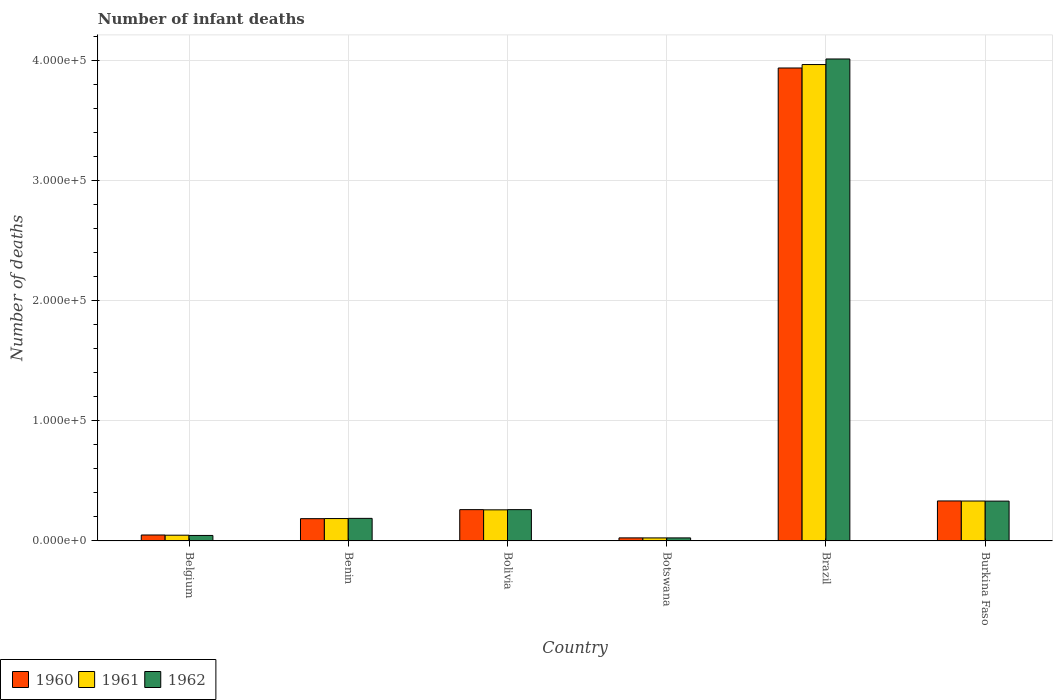How many different coloured bars are there?
Give a very brief answer. 3. How many groups of bars are there?
Give a very brief answer. 6. Are the number of bars per tick equal to the number of legend labels?
Offer a very short reply. Yes. In how many cases, is the number of bars for a given country not equal to the number of legend labels?
Make the answer very short. 0. What is the number of infant deaths in 1960 in Benin?
Offer a terse response. 1.85e+04. Across all countries, what is the maximum number of infant deaths in 1961?
Offer a terse response. 3.96e+05. Across all countries, what is the minimum number of infant deaths in 1962?
Offer a very short reply. 2530. In which country was the number of infant deaths in 1962 maximum?
Make the answer very short. Brazil. In which country was the number of infant deaths in 1960 minimum?
Make the answer very short. Botswana. What is the total number of infant deaths in 1962 in the graph?
Offer a terse response. 4.86e+05. What is the difference between the number of infant deaths in 1961 in Bolivia and that in Burkina Faso?
Provide a succinct answer. -7331. What is the difference between the number of infant deaths in 1960 in Belgium and the number of infant deaths in 1961 in Bolivia?
Your answer should be compact. -2.09e+04. What is the average number of infant deaths in 1961 per country?
Provide a short and direct response. 8.02e+04. What is the difference between the number of infant deaths of/in 1961 and number of infant deaths of/in 1962 in Bolivia?
Make the answer very short. -173. In how many countries, is the number of infant deaths in 1960 greater than 40000?
Provide a succinct answer. 1. What is the ratio of the number of infant deaths in 1961 in Benin to that in Brazil?
Provide a short and direct response. 0.05. What is the difference between the highest and the second highest number of infant deaths in 1962?
Provide a succinct answer. 7079. What is the difference between the highest and the lowest number of infant deaths in 1962?
Your answer should be very brief. 3.98e+05. Is the sum of the number of infant deaths in 1962 in Brazil and Burkina Faso greater than the maximum number of infant deaths in 1961 across all countries?
Provide a succinct answer. Yes. How many bars are there?
Give a very brief answer. 18. What is the difference between two consecutive major ticks on the Y-axis?
Make the answer very short. 1.00e+05. Are the values on the major ticks of Y-axis written in scientific E-notation?
Ensure brevity in your answer.  Yes. Does the graph contain any zero values?
Offer a very short reply. No. Where does the legend appear in the graph?
Your response must be concise. Bottom left. What is the title of the graph?
Ensure brevity in your answer.  Number of infant deaths. Does "1986" appear as one of the legend labels in the graph?
Offer a terse response. No. What is the label or title of the Y-axis?
Your answer should be very brief. Number of deaths. What is the Number of deaths of 1960 in Belgium?
Give a very brief answer. 4942. What is the Number of deaths of 1961 in Belgium?
Give a very brief answer. 4783. What is the Number of deaths of 1962 in Belgium?
Offer a very short reply. 4571. What is the Number of deaths in 1960 in Benin?
Offer a terse response. 1.85e+04. What is the Number of deaths in 1961 in Benin?
Offer a very short reply. 1.86e+04. What is the Number of deaths in 1962 in Benin?
Give a very brief answer. 1.88e+04. What is the Number of deaths in 1960 in Bolivia?
Offer a very short reply. 2.60e+04. What is the Number of deaths of 1961 in Bolivia?
Your response must be concise. 2.59e+04. What is the Number of deaths of 1962 in Bolivia?
Provide a succinct answer. 2.60e+04. What is the Number of deaths of 1960 in Botswana?
Provide a short and direct response. 2546. What is the Number of deaths of 1961 in Botswana?
Your response must be concise. 2516. What is the Number of deaths in 1962 in Botswana?
Your answer should be very brief. 2530. What is the Number of deaths in 1960 in Brazil?
Give a very brief answer. 3.93e+05. What is the Number of deaths in 1961 in Brazil?
Offer a very short reply. 3.96e+05. What is the Number of deaths in 1962 in Brazil?
Give a very brief answer. 4.01e+05. What is the Number of deaths in 1960 in Burkina Faso?
Give a very brief answer. 3.33e+04. What is the Number of deaths of 1961 in Burkina Faso?
Your response must be concise. 3.32e+04. What is the Number of deaths in 1962 in Burkina Faso?
Offer a terse response. 3.31e+04. Across all countries, what is the maximum Number of deaths in 1960?
Your answer should be very brief. 3.93e+05. Across all countries, what is the maximum Number of deaths of 1961?
Provide a short and direct response. 3.96e+05. Across all countries, what is the maximum Number of deaths of 1962?
Keep it short and to the point. 4.01e+05. Across all countries, what is the minimum Number of deaths in 1960?
Keep it short and to the point. 2546. Across all countries, what is the minimum Number of deaths in 1961?
Your answer should be compact. 2516. Across all countries, what is the minimum Number of deaths of 1962?
Offer a terse response. 2530. What is the total Number of deaths of 1960 in the graph?
Give a very brief answer. 4.79e+05. What is the total Number of deaths of 1961 in the graph?
Provide a short and direct response. 4.81e+05. What is the total Number of deaths of 1962 in the graph?
Make the answer very short. 4.86e+05. What is the difference between the Number of deaths in 1960 in Belgium and that in Benin?
Your response must be concise. -1.36e+04. What is the difference between the Number of deaths in 1961 in Belgium and that in Benin?
Offer a terse response. -1.38e+04. What is the difference between the Number of deaths of 1962 in Belgium and that in Benin?
Provide a succinct answer. -1.42e+04. What is the difference between the Number of deaths in 1960 in Belgium and that in Bolivia?
Provide a short and direct response. -2.11e+04. What is the difference between the Number of deaths of 1961 in Belgium and that in Bolivia?
Make the answer very short. -2.11e+04. What is the difference between the Number of deaths in 1962 in Belgium and that in Bolivia?
Ensure brevity in your answer.  -2.15e+04. What is the difference between the Number of deaths of 1960 in Belgium and that in Botswana?
Ensure brevity in your answer.  2396. What is the difference between the Number of deaths of 1961 in Belgium and that in Botswana?
Keep it short and to the point. 2267. What is the difference between the Number of deaths of 1962 in Belgium and that in Botswana?
Provide a short and direct response. 2041. What is the difference between the Number of deaths in 1960 in Belgium and that in Brazil?
Your response must be concise. -3.88e+05. What is the difference between the Number of deaths in 1961 in Belgium and that in Brazil?
Offer a terse response. -3.91e+05. What is the difference between the Number of deaths of 1962 in Belgium and that in Brazil?
Keep it short and to the point. -3.96e+05. What is the difference between the Number of deaths in 1960 in Belgium and that in Burkina Faso?
Provide a succinct answer. -2.83e+04. What is the difference between the Number of deaths of 1961 in Belgium and that in Burkina Faso?
Your answer should be very brief. -2.84e+04. What is the difference between the Number of deaths in 1962 in Belgium and that in Burkina Faso?
Your answer should be compact. -2.86e+04. What is the difference between the Number of deaths in 1960 in Benin and that in Bolivia?
Your answer should be compact. -7506. What is the difference between the Number of deaths in 1961 in Benin and that in Bolivia?
Your answer should be very brief. -7255. What is the difference between the Number of deaths of 1962 in Benin and that in Bolivia?
Your answer should be very brief. -7273. What is the difference between the Number of deaths in 1960 in Benin and that in Botswana?
Your response must be concise. 1.60e+04. What is the difference between the Number of deaths in 1961 in Benin and that in Botswana?
Give a very brief answer. 1.61e+04. What is the difference between the Number of deaths of 1962 in Benin and that in Botswana?
Your answer should be very brief. 1.62e+04. What is the difference between the Number of deaths in 1960 in Benin and that in Brazil?
Your answer should be very brief. -3.75e+05. What is the difference between the Number of deaths of 1961 in Benin and that in Brazil?
Your answer should be compact. -3.78e+05. What is the difference between the Number of deaths in 1962 in Benin and that in Brazil?
Give a very brief answer. -3.82e+05. What is the difference between the Number of deaths of 1960 in Benin and that in Burkina Faso?
Ensure brevity in your answer.  -1.47e+04. What is the difference between the Number of deaths of 1961 in Benin and that in Burkina Faso?
Ensure brevity in your answer.  -1.46e+04. What is the difference between the Number of deaths in 1962 in Benin and that in Burkina Faso?
Offer a very short reply. -1.44e+04. What is the difference between the Number of deaths of 1960 in Bolivia and that in Botswana?
Ensure brevity in your answer.  2.35e+04. What is the difference between the Number of deaths in 1961 in Bolivia and that in Botswana?
Offer a very short reply. 2.34e+04. What is the difference between the Number of deaths in 1962 in Bolivia and that in Botswana?
Your answer should be very brief. 2.35e+04. What is the difference between the Number of deaths in 1960 in Bolivia and that in Brazil?
Offer a terse response. -3.67e+05. What is the difference between the Number of deaths of 1961 in Bolivia and that in Brazil?
Offer a very short reply. -3.70e+05. What is the difference between the Number of deaths of 1962 in Bolivia and that in Brazil?
Your response must be concise. -3.75e+05. What is the difference between the Number of deaths in 1960 in Bolivia and that in Burkina Faso?
Ensure brevity in your answer.  -7229. What is the difference between the Number of deaths of 1961 in Bolivia and that in Burkina Faso?
Ensure brevity in your answer.  -7331. What is the difference between the Number of deaths of 1962 in Bolivia and that in Burkina Faso?
Ensure brevity in your answer.  -7079. What is the difference between the Number of deaths of 1960 in Botswana and that in Brazil?
Your answer should be very brief. -3.91e+05. What is the difference between the Number of deaths of 1961 in Botswana and that in Brazil?
Offer a very short reply. -3.94e+05. What is the difference between the Number of deaths in 1962 in Botswana and that in Brazil?
Offer a very short reply. -3.98e+05. What is the difference between the Number of deaths of 1960 in Botswana and that in Burkina Faso?
Make the answer very short. -3.07e+04. What is the difference between the Number of deaths of 1961 in Botswana and that in Burkina Faso?
Your answer should be compact. -3.07e+04. What is the difference between the Number of deaths in 1962 in Botswana and that in Burkina Faso?
Provide a succinct answer. -3.06e+04. What is the difference between the Number of deaths in 1960 in Brazil and that in Burkina Faso?
Your answer should be very brief. 3.60e+05. What is the difference between the Number of deaths of 1961 in Brazil and that in Burkina Faso?
Offer a terse response. 3.63e+05. What is the difference between the Number of deaths of 1962 in Brazil and that in Burkina Faso?
Offer a terse response. 3.68e+05. What is the difference between the Number of deaths in 1960 in Belgium and the Number of deaths in 1961 in Benin?
Give a very brief answer. -1.37e+04. What is the difference between the Number of deaths of 1960 in Belgium and the Number of deaths of 1962 in Benin?
Offer a very short reply. -1.38e+04. What is the difference between the Number of deaths in 1961 in Belgium and the Number of deaths in 1962 in Benin?
Provide a succinct answer. -1.40e+04. What is the difference between the Number of deaths in 1960 in Belgium and the Number of deaths in 1961 in Bolivia?
Your response must be concise. -2.09e+04. What is the difference between the Number of deaths of 1960 in Belgium and the Number of deaths of 1962 in Bolivia?
Your answer should be very brief. -2.11e+04. What is the difference between the Number of deaths in 1961 in Belgium and the Number of deaths in 1962 in Bolivia?
Keep it short and to the point. -2.13e+04. What is the difference between the Number of deaths of 1960 in Belgium and the Number of deaths of 1961 in Botswana?
Your answer should be very brief. 2426. What is the difference between the Number of deaths in 1960 in Belgium and the Number of deaths in 1962 in Botswana?
Offer a very short reply. 2412. What is the difference between the Number of deaths in 1961 in Belgium and the Number of deaths in 1962 in Botswana?
Offer a terse response. 2253. What is the difference between the Number of deaths in 1960 in Belgium and the Number of deaths in 1961 in Brazil?
Ensure brevity in your answer.  -3.91e+05. What is the difference between the Number of deaths of 1960 in Belgium and the Number of deaths of 1962 in Brazil?
Keep it short and to the point. -3.96e+05. What is the difference between the Number of deaths in 1961 in Belgium and the Number of deaths in 1962 in Brazil?
Offer a terse response. -3.96e+05. What is the difference between the Number of deaths of 1960 in Belgium and the Number of deaths of 1961 in Burkina Faso?
Your answer should be compact. -2.83e+04. What is the difference between the Number of deaths in 1960 in Belgium and the Number of deaths in 1962 in Burkina Faso?
Offer a very short reply. -2.82e+04. What is the difference between the Number of deaths in 1961 in Belgium and the Number of deaths in 1962 in Burkina Faso?
Provide a short and direct response. -2.83e+04. What is the difference between the Number of deaths of 1960 in Benin and the Number of deaths of 1961 in Bolivia?
Your answer should be compact. -7342. What is the difference between the Number of deaths in 1960 in Benin and the Number of deaths in 1962 in Bolivia?
Your answer should be compact. -7515. What is the difference between the Number of deaths in 1961 in Benin and the Number of deaths in 1962 in Bolivia?
Your answer should be very brief. -7428. What is the difference between the Number of deaths of 1960 in Benin and the Number of deaths of 1961 in Botswana?
Offer a very short reply. 1.60e+04. What is the difference between the Number of deaths in 1960 in Benin and the Number of deaths in 1962 in Botswana?
Your response must be concise. 1.60e+04. What is the difference between the Number of deaths in 1961 in Benin and the Number of deaths in 1962 in Botswana?
Keep it short and to the point. 1.61e+04. What is the difference between the Number of deaths in 1960 in Benin and the Number of deaths in 1961 in Brazil?
Your response must be concise. -3.78e+05. What is the difference between the Number of deaths of 1960 in Benin and the Number of deaths of 1962 in Brazil?
Ensure brevity in your answer.  -3.82e+05. What is the difference between the Number of deaths in 1961 in Benin and the Number of deaths in 1962 in Brazil?
Ensure brevity in your answer.  -3.82e+05. What is the difference between the Number of deaths in 1960 in Benin and the Number of deaths in 1961 in Burkina Faso?
Your answer should be very brief. -1.47e+04. What is the difference between the Number of deaths of 1960 in Benin and the Number of deaths of 1962 in Burkina Faso?
Provide a short and direct response. -1.46e+04. What is the difference between the Number of deaths in 1961 in Benin and the Number of deaths in 1962 in Burkina Faso?
Provide a short and direct response. -1.45e+04. What is the difference between the Number of deaths in 1960 in Bolivia and the Number of deaths in 1961 in Botswana?
Keep it short and to the point. 2.35e+04. What is the difference between the Number of deaths of 1960 in Bolivia and the Number of deaths of 1962 in Botswana?
Make the answer very short. 2.35e+04. What is the difference between the Number of deaths of 1961 in Bolivia and the Number of deaths of 1962 in Botswana?
Give a very brief answer. 2.33e+04. What is the difference between the Number of deaths in 1960 in Bolivia and the Number of deaths in 1961 in Brazil?
Keep it short and to the point. -3.70e+05. What is the difference between the Number of deaths in 1960 in Bolivia and the Number of deaths in 1962 in Brazil?
Your answer should be compact. -3.75e+05. What is the difference between the Number of deaths in 1961 in Bolivia and the Number of deaths in 1962 in Brazil?
Your answer should be very brief. -3.75e+05. What is the difference between the Number of deaths in 1960 in Bolivia and the Number of deaths in 1961 in Burkina Faso?
Provide a short and direct response. -7167. What is the difference between the Number of deaths in 1960 in Bolivia and the Number of deaths in 1962 in Burkina Faso?
Ensure brevity in your answer.  -7088. What is the difference between the Number of deaths of 1961 in Bolivia and the Number of deaths of 1962 in Burkina Faso?
Make the answer very short. -7252. What is the difference between the Number of deaths in 1960 in Botswana and the Number of deaths in 1961 in Brazil?
Keep it short and to the point. -3.94e+05. What is the difference between the Number of deaths of 1960 in Botswana and the Number of deaths of 1962 in Brazil?
Your answer should be very brief. -3.98e+05. What is the difference between the Number of deaths of 1961 in Botswana and the Number of deaths of 1962 in Brazil?
Provide a succinct answer. -3.98e+05. What is the difference between the Number of deaths of 1960 in Botswana and the Number of deaths of 1961 in Burkina Faso?
Your answer should be very brief. -3.07e+04. What is the difference between the Number of deaths in 1960 in Botswana and the Number of deaths in 1962 in Burkina Faso?
Give a very brief answer. -3.06e+04. What is the difference between the Number of deaths in 1961 in Botswana and the Number of deaths in 1962 in Burkina Faso?
Give a very brief answer. -3.06e+04. What is the difference between the Number of deaths in 1960 in Brazil and the Number of deaths in 1961 in Burkina Faso?
Keep it short and to the point. 3.60e+05. What is the difference between the Number of deaths in 1960 in Brazil and the Number of deaths in 1962 in Burkina Faso?
Offer a terse response. 3.60e+05. What is the difference between the Number of deaths in 1961 in Brazil and the Number of deaths in 1962 in Burkina Faso?
Offer a terse response. 3.63e+05. What is the average Number of deaths of 1960 per country?
Offer a very short reply. 7.98e+04. What is the average Number of deaths of 1961 per country?
Offer a very short reply. 8.02e+04. What is the average Number of deaths in 1962 per country?
Your answer should be very brief. 8.10e+04. What is the difference between the Number of deaths in 1960 and Number of deaths in 1961 in Belgium?
Give a very brief answer. 159. What is the difference between the Number of deaths of 1960 and Number of deaths of 1962 in Belgium?
Ensure brevity in your answer.  371. What is the difference between the Number of deaths of 1961 and Number of deaths of 1962 in Belgium?
Your answer should be compact. 212. What is the difference between the Number of deaths in 1960 and Number of deaths in 1961 in Benin?
Give a very brief answer. -87. What is the difference between the Number of deaths of 1960 and Number of deaths of 1962 in Benin?
Ensure brevity in your answer.  -242. What is the difference between the Number of deaths of 1961 and Number of deaths of 1962 in Benin?
Make the answer very short. -155. What is the difference between the Number of deaths in 1960 and Number of deaths in 1961 in Bolivia?
Your answer should be compact. 164. What is the difference between the Number of deaths of 1961 and Number of deaths of 1962 in Bolivia?
Give a very brief answer. -173. What is the difference between the Number of deaths of 1960 and Number of deaths of 1961 in Botswana?
Your answer should be very brief. 30. What is the difference between the Number of deaths in 1960 and Number of deaths in 1961 in Brazil?
Your answer should be compact. -2856. What is the difference between the Number of deaths of 1960 and Number of deaths of 1962 in Brazil?
Make the answer very short. -7497. What is the difference between the Number of deaths in 1961 and Number of deaths in 1962 in Brazil?
Ensure brevity in your answer.  -4641. What is the difference between the Number of deaths in 1960 and Number of deaths in 1961 in Burkina Faso?
Offer a terse response. 62. What is the difference between the Number of deaths in 1960 and Number of deaths in 1962 in Burkina Faso?
Your answer should be very brief. 141. What is the difference between the Number of deaths of 1961 and Number of deaths of 1962 in Burkina Faso?
Provide a succinct answer. 79. What is the ratio of the Number of deaths of 1960 in Belgium to that in Benin?
Offer a very short reply. 0.27. What is the ratio of the Number of deaths in 1961 in Belgium to that in Benin?
Provide a succinct answer. 0.26. What is the ratio of the Number of deaths of 1962 in Belgium to that in Benin?
Your answer should be very brief. 0.24. What is the ratio of the Number of deaths of 1960 in Belgium to that in Bolivia?
Offer a terse response. 0.19. What is the ratio of the Number of deaths in 1961 in Belgium to that in Bolivia?
Your response must be concise. 0.18. What is the ratio of the Number of deaths in 1962 in Belgium to that in Bolivia?
Your answer should be very brief. 0.18. What is the ratio of the Number of deaths in 1960 in Belgium to that in Botswana?
Your answer should be very brief. 1.94. What is the ratio of the Number of deaths of 1961 in Belgium to that in Botswana?
Keep it short and to the point. 1.9. What is the ratio of the Number of deaths in 1962 in Belgium to that in Botswana?
Offer a terse response. 1.81. What is the ratio of the Number of deaths in 1960 in Belgium to that in Brazil?
Keep it short and to the point. 0.01. What is the ratio of the Number of deaths in 1961 in Belgium to that in Brazil?
Offer a terse response. 0.01. What is the ratio of the Number of deaths in 1962 in Belgium to that in Brazil?
Give a very brief answer. 0.01. What is the ratio of the Number of deaths of 1960 in Belgium to that in Burkina Faso?
Give a very brief answer. 0.15. What is the ratio of the Number of deaths in 1961 in Belgium to that in Burkina Faso?
Give a very brief answer. 0.14. What is the ratio of the Number of deaths in 1962 in Belgium to that in Burkina Faso?
Make the answer very short. 0.14. What is the ratio of the Number of deaths in 1960 in Benin to that in Bolivia?
Your answer should be very brief. 0.71. What is the ratio of the Number of deaths in 1961 in Benin to that in Bolivia?
Provide a succinct answer. 0.72. What is the ratio of the Number of deaths in 1962 in Benin to that in Bolivia?
Provide a short and direct response. 0.72. What is the ratio of the Number of deaths in 1960 in Benin to that in Botswana?
Keep it short and to the point. 7.28. What is the ratio of the Number of deaths in 1961 in Benin to that in Botswana?
Offer a very short reply. 7.4. What is the ratio of the Number of deaths in 1962 in Benin to that in Botswana?
Offer a terse response. 7.42. What is the ratio of the Number of deaths of 1960 in Benin to that in Brazil?
Offer a very short reply. 0.05. What is the ratio of the Number of deaths in 1961 in Benin to that in Brazil?
Ensure brevity in your answer.  0.05. What is the ratio of the Number of deaths in 1962 in Benin to that in Brazil?
Ensure brevity in your answer.  0.05. What is the ratio of the Number of deaths in 1960 in Benin to that in Burkina Faso?
Offer a terse response. 0.56. What is the ratio of the Number of deaths of 1961 in Benin to that in Burkina Faso?
Your answer should be very brief. 0.56. What is the ratio of the Number of deaths in 1962 in Benin to that in Burkina Faso?
Provide a succinct answer. 0.57. What is the ratio of the Number of deaths in 1960 in Bolivia to that in Botswana?
Your answer should be very brief. 10.23. What is the ratio of the Number of deaths of 1961 in Bolivia to that in Botswana?
Offer a very short reply. 10.28. What is the ratio of the Number of deaths in 1962 in Bolivia to that in Botswana?
Provide a succinct answer. 10.29. What is the ratio of the Number of deaths of 1960 in Bolivia to that in Brazil?
Ensure brevity in your answer.  0.07. What is the ratio of the Number of deaths of 1961 in Bolivia to that in Brazil?
Provide a short and direct response. 0.07. What is the ratio of the Number of deaths in 1962 in Bolivia to that in Brazil?
Provide a succinct answer. 0.07. What is the ratio of the Number of deaths in 1960 in Bolivia to that in Burkina Faso?
Ensure brevity in your answer.  0.78. What is the ratio of the Number of deaths in 1961 in Bolivia to that in Burkina Faso?
Your response must be concise. 0.78. What is the ratio of the Number of deaths of 1962 in Bolivia to that in Burkina Faso?
Offer a very short reply. 0.79. What is the ratio of the Number of deaths in 1960 in Botswana to that in Brazil?
Your answer should be very brief. 0.01. What is the ratio of the Number of deaths in 1961 in Botswana to that in Brazil?
Your answer should be compact. 0.01. What is the ratio of the Number of deaths of 1962 in Botswana to that in Brazil?
Make the answer very short. 0.01. What is the ratio of the Number of deaths in 1960 in Botswana to that in Burkina Faso?
Keep it short and to the point. 0.08. What is the ratio of the Number of deaths of 1961 in Botswana to that in Burkina Faso?
Your response must be concise. 0.08. What is the ratio of the Number of deaths in 1962 in Botswana to that in Burkina Faso?
Provide a succinct answer. 0.08. What is the ratio of the Number of deaths in 1960 in Brazil to that in Burkina Faso?
Your answer should be compact. 11.83. What is the ratio of the Number of deaths of 1961 in Brazil to that in Burkina Faso?
Provide a short and direct response. 11.93. What is the ratio of the Number of deaths in 1962 in Brazil to that in Burkina Faso?
Your answer should be very brief. 12.1. What is the difference between the highest and the second highest Number of deaths in 1960?
Offer a very short reply. 3.60e+05. What is the difference between the highest and the second highest Number of deaths of 1961?
Make the answer very short. 3.63e+05. What is the difference between the highest and the second highest Number of deaths in 1962?
Provide a short and direct response. 3.68e+05. What is the difference between the highest and the lowest Number of deaths in 1960?
Offer a terse response. 3.91e+05. What is the difference between the highest and the lowest Number of deaths in 1961?
Provide a short and direct response. 3.94e+05. What is the difference between the highest and the lowest Number of deaths of 1962?
Your answer should be very brief. 3.98e+05. 